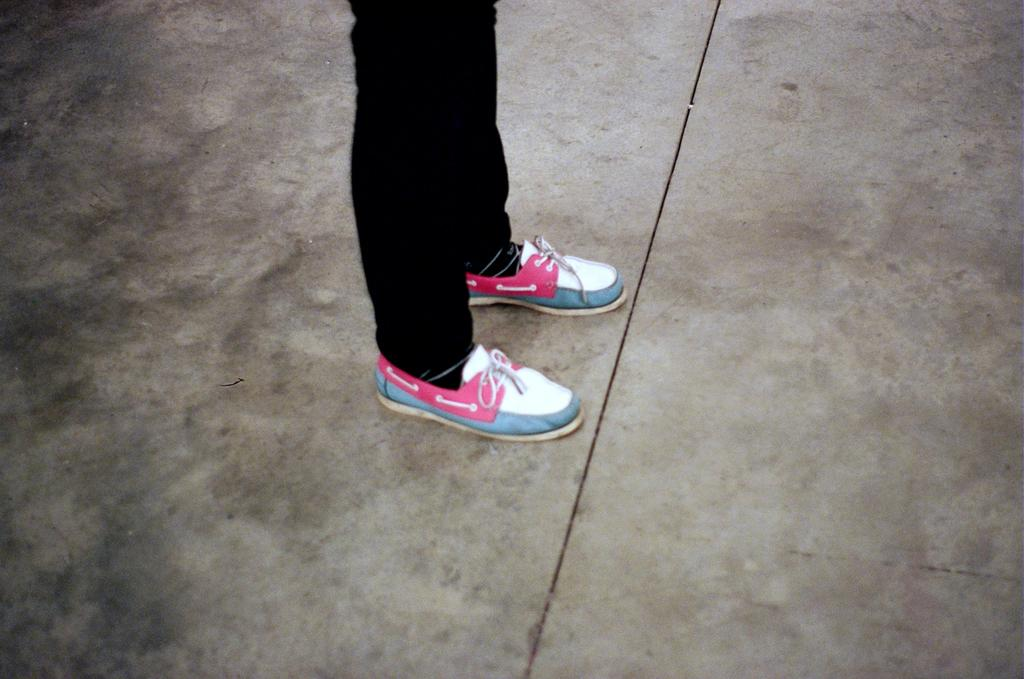What body part is visible in the image? There is a person's leg in the image. What is the person wearing on their feet? The person is wearing footwear. What color are the pants the person is wearing? The person is wearing black color pants. Is there any smoke coming from the person's foot in the image? No, there is no smoke present in the image. 